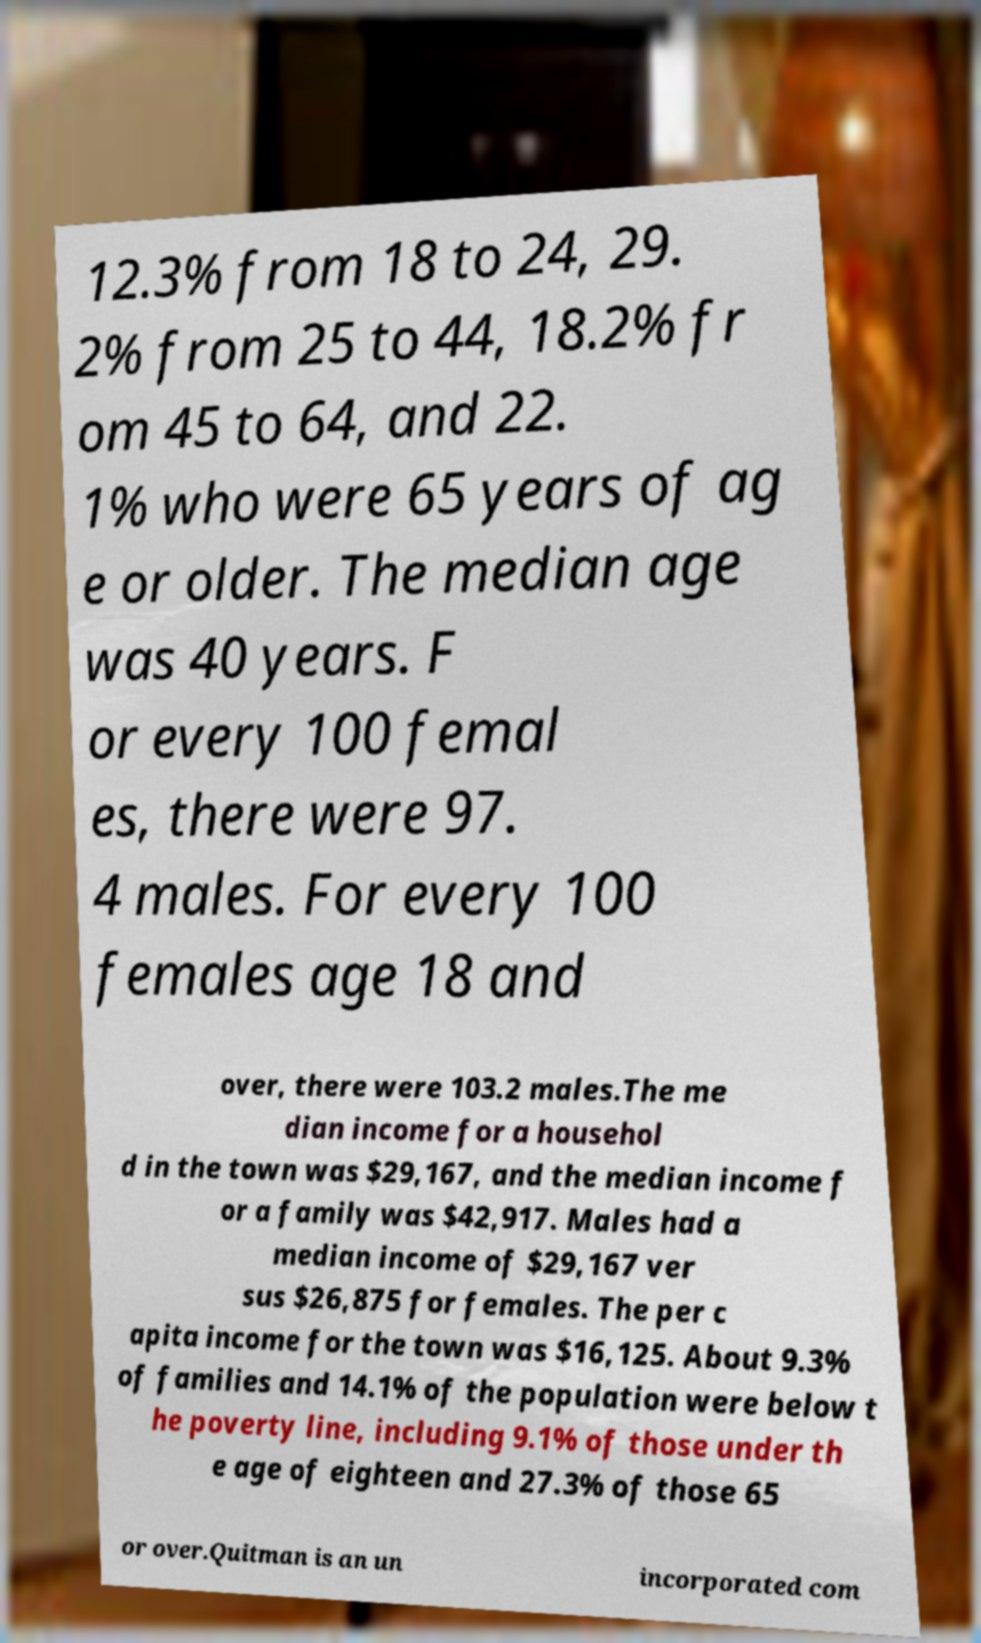Could you assist in decoding the text presented in this image and type it out clearly? 12.3% from 18 to 24, 29. 2% from 25 to 44, 18.2% fr om 45 to 64, and 22. 1% who were 65 years of ag e or older. The median age was 40 years. F or every 100 femal es, there were 97. 4 males. For every 100 females age 18 and over, there were 103.2 males.The me dian income for a househol d in the town was $29,167, and the median income f or a family was $42,917. Males had a median income of $29,167 ver sus $26,875 for females. The per c apita income for the town was $16,125. About 9.3% of families and 14.1% of the population were below t he poverty line, including 9.1% of those under th e age of eighteen and 27.3% of those 65 or over.Quitman is an un incorporated com 